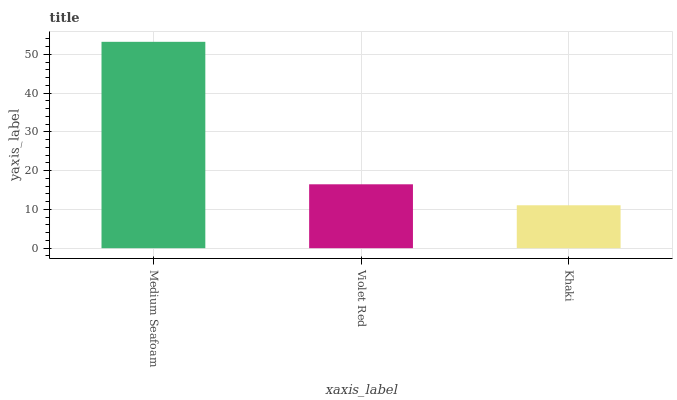Is Violet Red the minimum?
Answer yes or no. No. Is Violet Red the maximum?
Answer yes or no. No. Is Medium Seafoam greater than Violet Red?
Answer yes or no. Yes. Is Violet Red less than Medium Seafoam?
Answer yes or no. Yes. Is Violet Red greater than Medium Seafoam?
Answer yes or no. No. Is Medium Seafoam less than Violet Red?
Answer yes or no. No. Is Violet Red the high median?
Answer yes or no. Yes. Is Violet Red the low median?
Answer yes or no. Yes. Is Medium Seafoam the high median?
Answer yes or no. No. Is Khaki the low median?
Answer yes or no. No. 